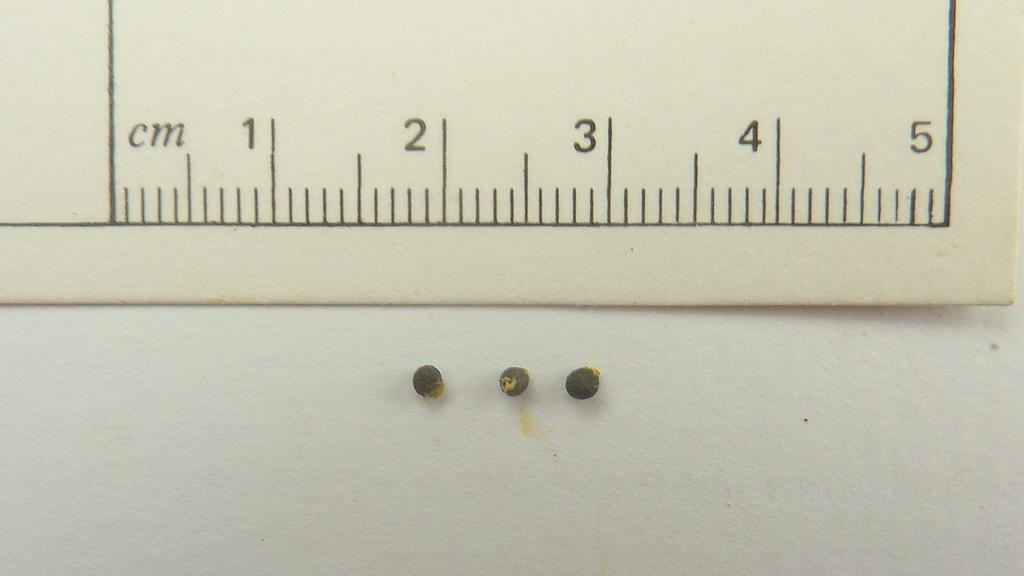<image>
Create a compact narrative representing the image presented. a ruler with cm measurements and three small buttons below it. 